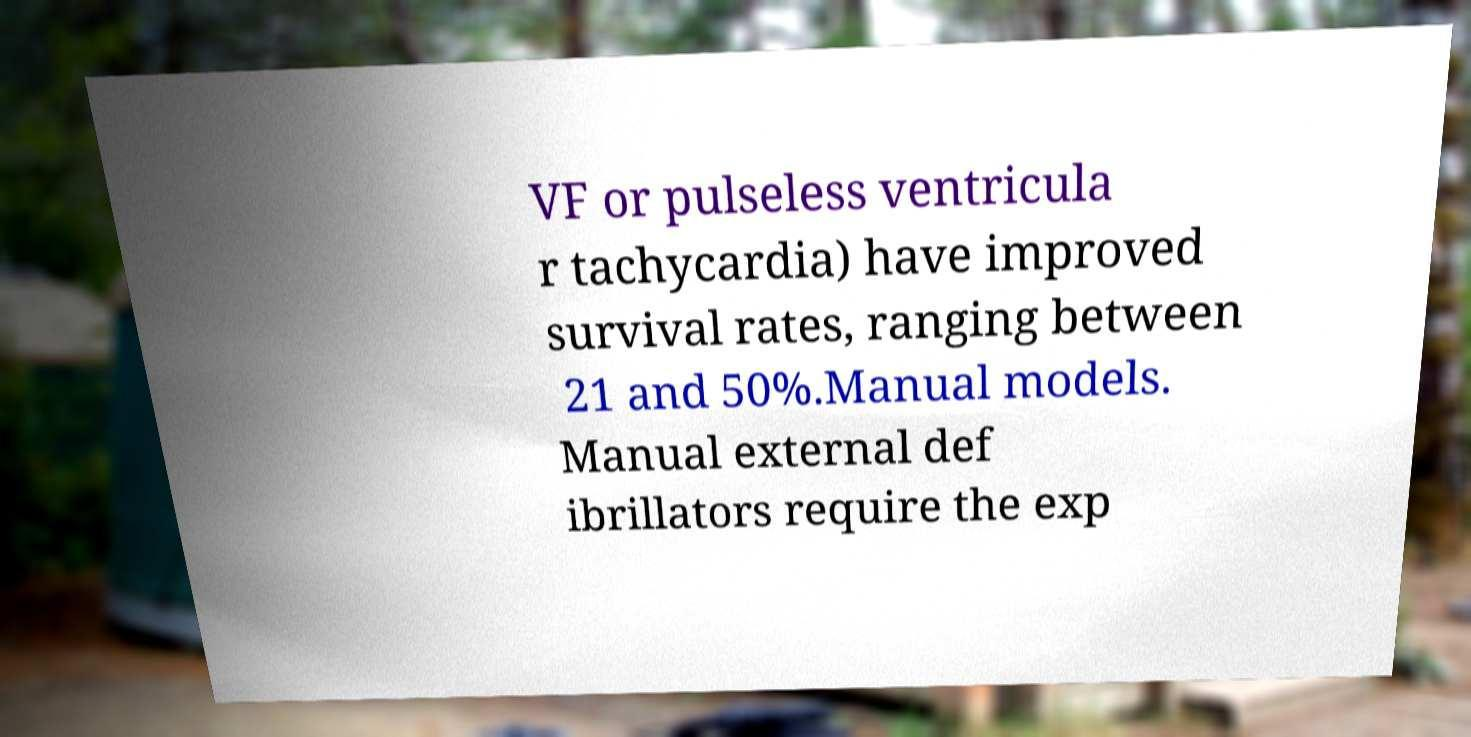Please read and relay the text visible in this image. What does it say? VF or pulseless ventricula r tachycardia) have improved survival rates, ranging between 21 and 50%.Manual models. Manual external def ibrillators require the exp 